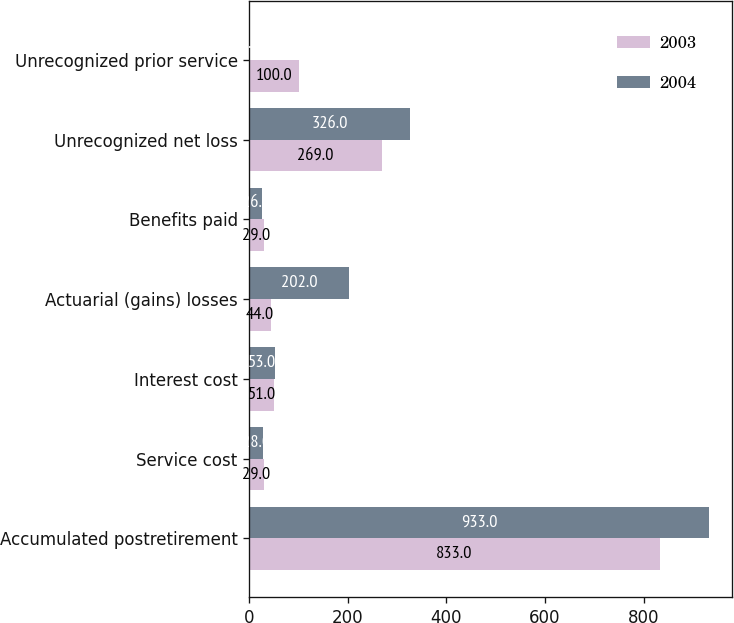<chart> <loc_0><loc_0><loc_500><loc_500><stacked_bar_chart><ecel><fcel>Accumulated postretirement<fcel>Service cost<fcel>Interest cost<fcel>Actuarial (gains) losses<fcel>Benefits paid<fcel>Unrecognized net loss<fcel>Unrecognized prior service<nl><fcel>2003<fcel>833<fcel>29<fcel>51<fcel>44<fcel>29<fcel>269<fcel>100<nl><fcel>2004<fcel>933<fcel>28<fcel>53<fcel>202<fcel>26<fcel>326<fcel>2<nl></chart> 